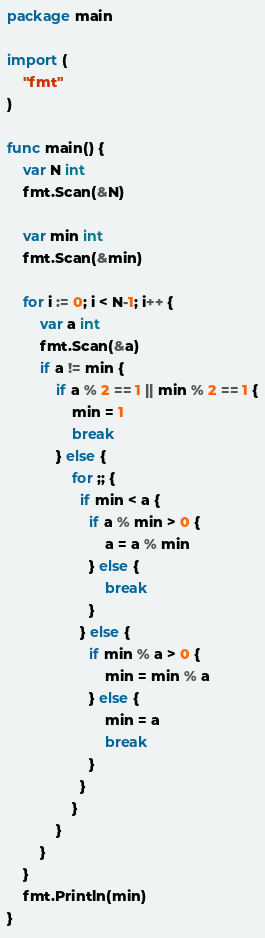<code> <loc_0><loc_0><loc_500><loc_500><_Go_>package main

import (
	"fmt"
)

func main() {
	var N int
	fmt.Scan(&N)

	var min int
	fmt.Scan(&min)
	
	for i := 0; i < N-1; i++ {
		var a int
		fmt.Scan(&a)
		if a != min {
			if a % 2 == 1 || min % 2 == 1 {
				min = 1
				break
			} else {
                for ;; {
                  if min < a {
                    if a % min > 0 {
                        a = a % min
                    } else {
                        break
                    }
                  } else {
                    if min % a > 0 {
                        min = min % a
                    } else {
                        min = a
                        break
                    }
                  }
                }
			}
		}
	}
	fmt.Println(min)
}
</code> 